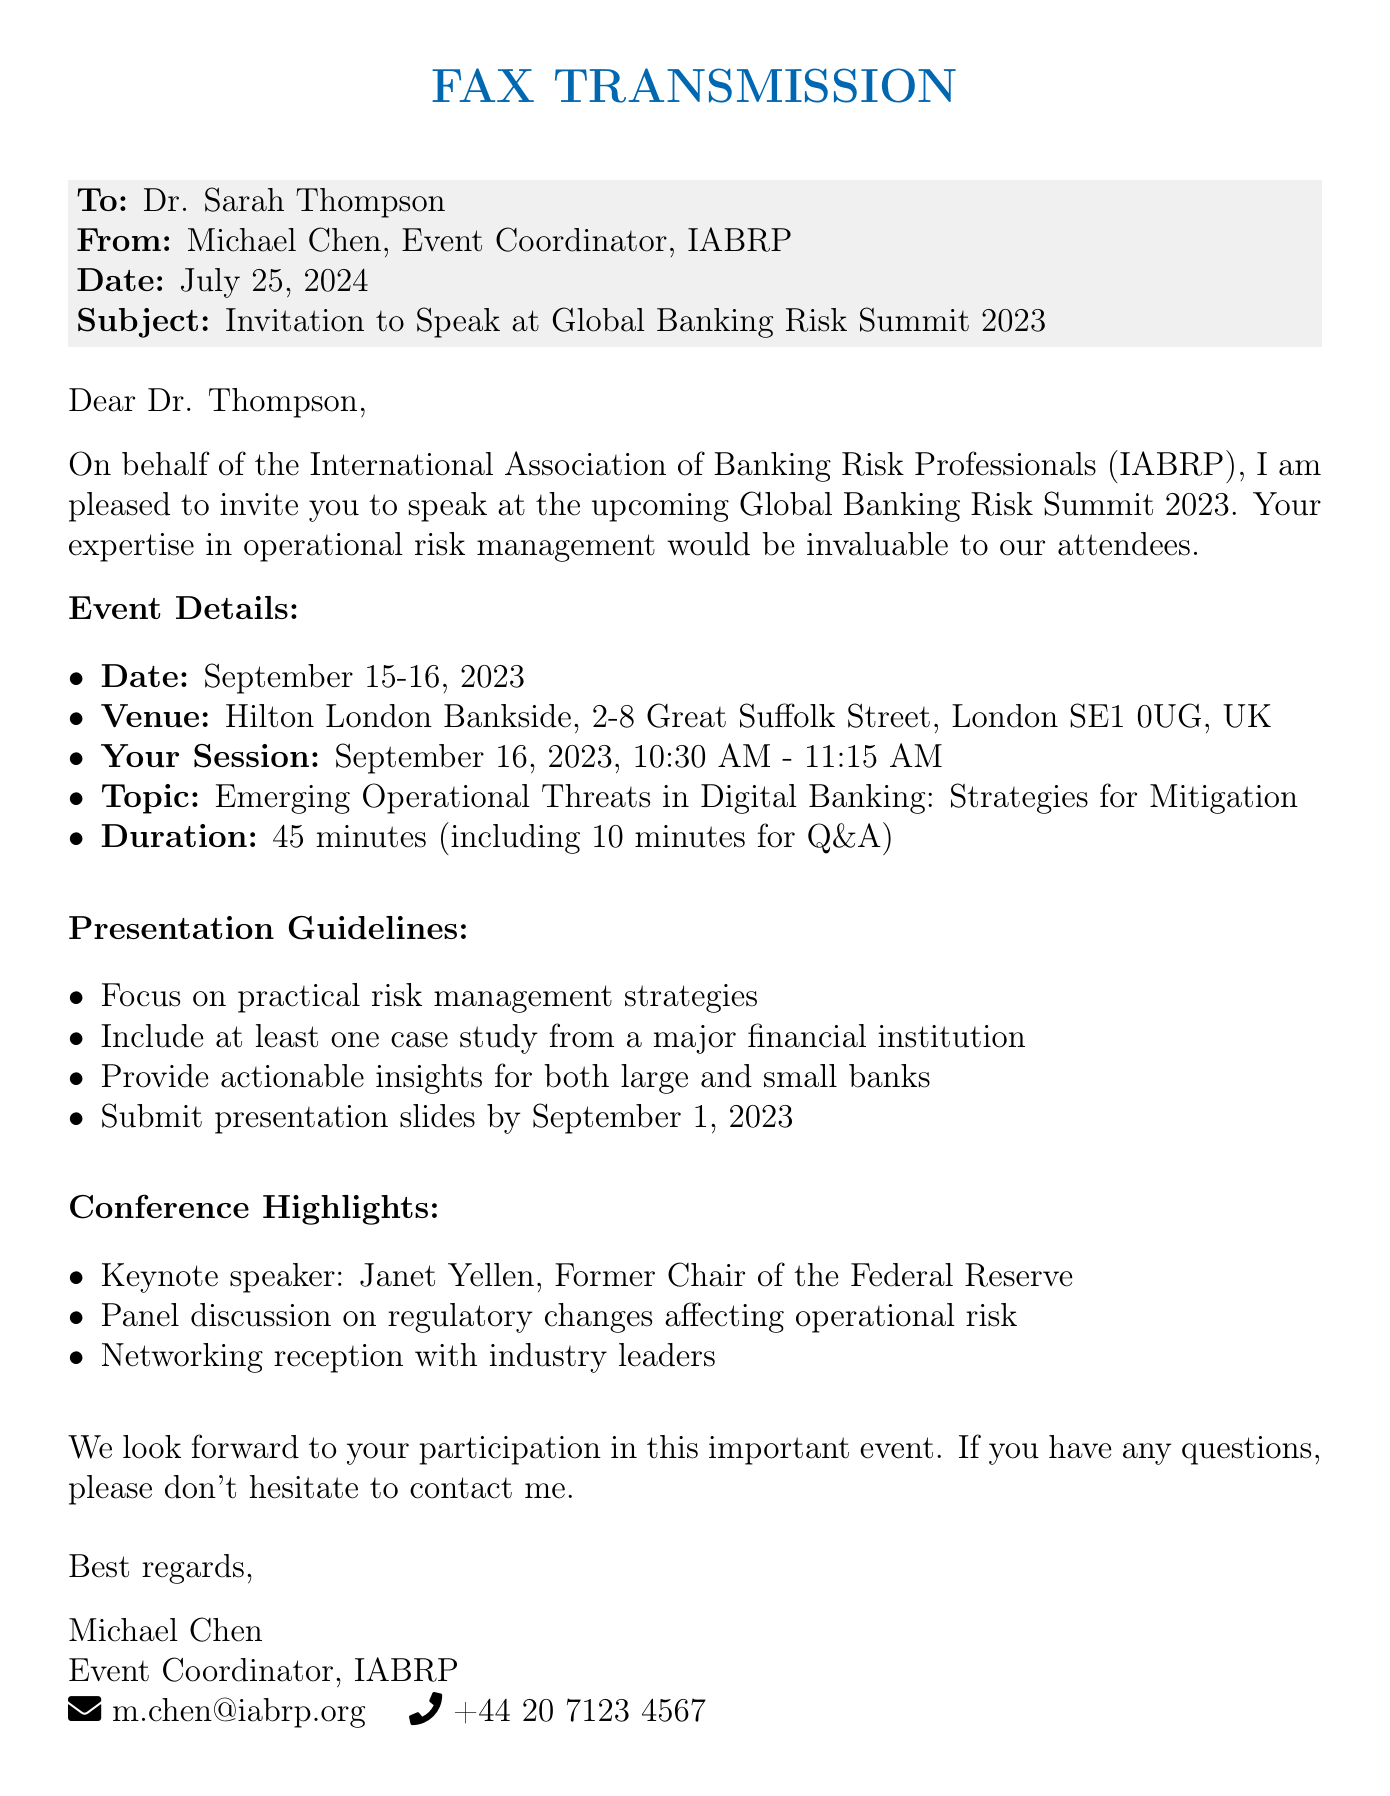What is the name of the event? The name of the event is mentioned in the document as the Global Banking Risk Summit 2023.
Answer: Global Banking Risk Summit 2023 Who is the keynote speaker? The document states that Janet Yellen, Former Chair of the Federal Reserve, is the keynote speaker.
Answer: Janet Yellen What are the dates of the conference? The dates of the conference are explicitly stated in the document as September 15-16, 2023.
Answer: September 15-16, 2023 What is the topic of Dr. Thompson's session? The document indicates that the topic of Dr. Thompson's session is "Emerging Operational Threats in Digital Banking: Strategies for Mitigation."
Answer: Emerging Operational Threats in Digital Banking: Strategies for Mitigation How long is Dr. Thompson's presentation scheduled for? The duration of Dr. Thompson's presentation, including Q&A, is given in the document.
Answer: 45 minutes When is the deadline to submit presentation slides? The document specifies that the deadline to submit presentation slides is September 1, 2023.
Answer: September 1, 2023 Where is the venue of the conference? The venue for the conference is detailed in the document as Hilton London Bankside, 2-8 Great Suffolk Street, London SE1 0UG, UK.
Answer: Hilton London Bankside, 2-8 Great Suffolk Street, London SE1 0UG, UK What is expected to be included in the presentation according to the guidelines? The guidelines request to focus on practical risk management strategies and include a case study.
Answer: Focus on practical risk management strategies and include a case study What is the contact email for Michael Chen? The email address for Michael Chen is provided in the document.
Answer: m.chen@iabrp.org 